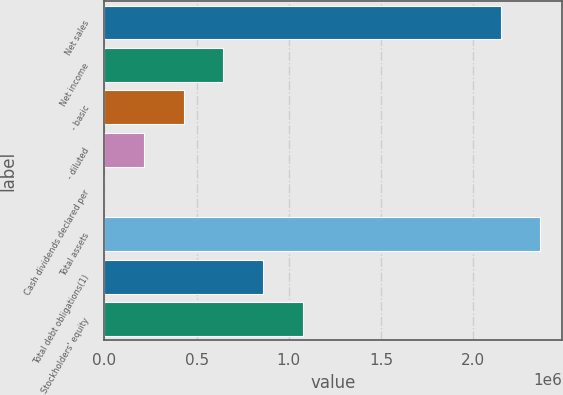Convert chart. <chart><loc_0><loc_0><loc_500><loc_500><bar_chart><fcel>Net sales<fcel>Net income<fcel>- basic<fcel>- diluted<fcel>Cash dividends declared per<fcel>Total assets<fcel>Total debt obligations(1)<fcel>Stockholders' equity<nl><fcel>2.14759e+06<fcel>645852<fcel>430568<fcel>215285<fcel>0.6<fcel>2.36287e+06<fcel>861136<fcel>1.07642e+06<nl></chart> 